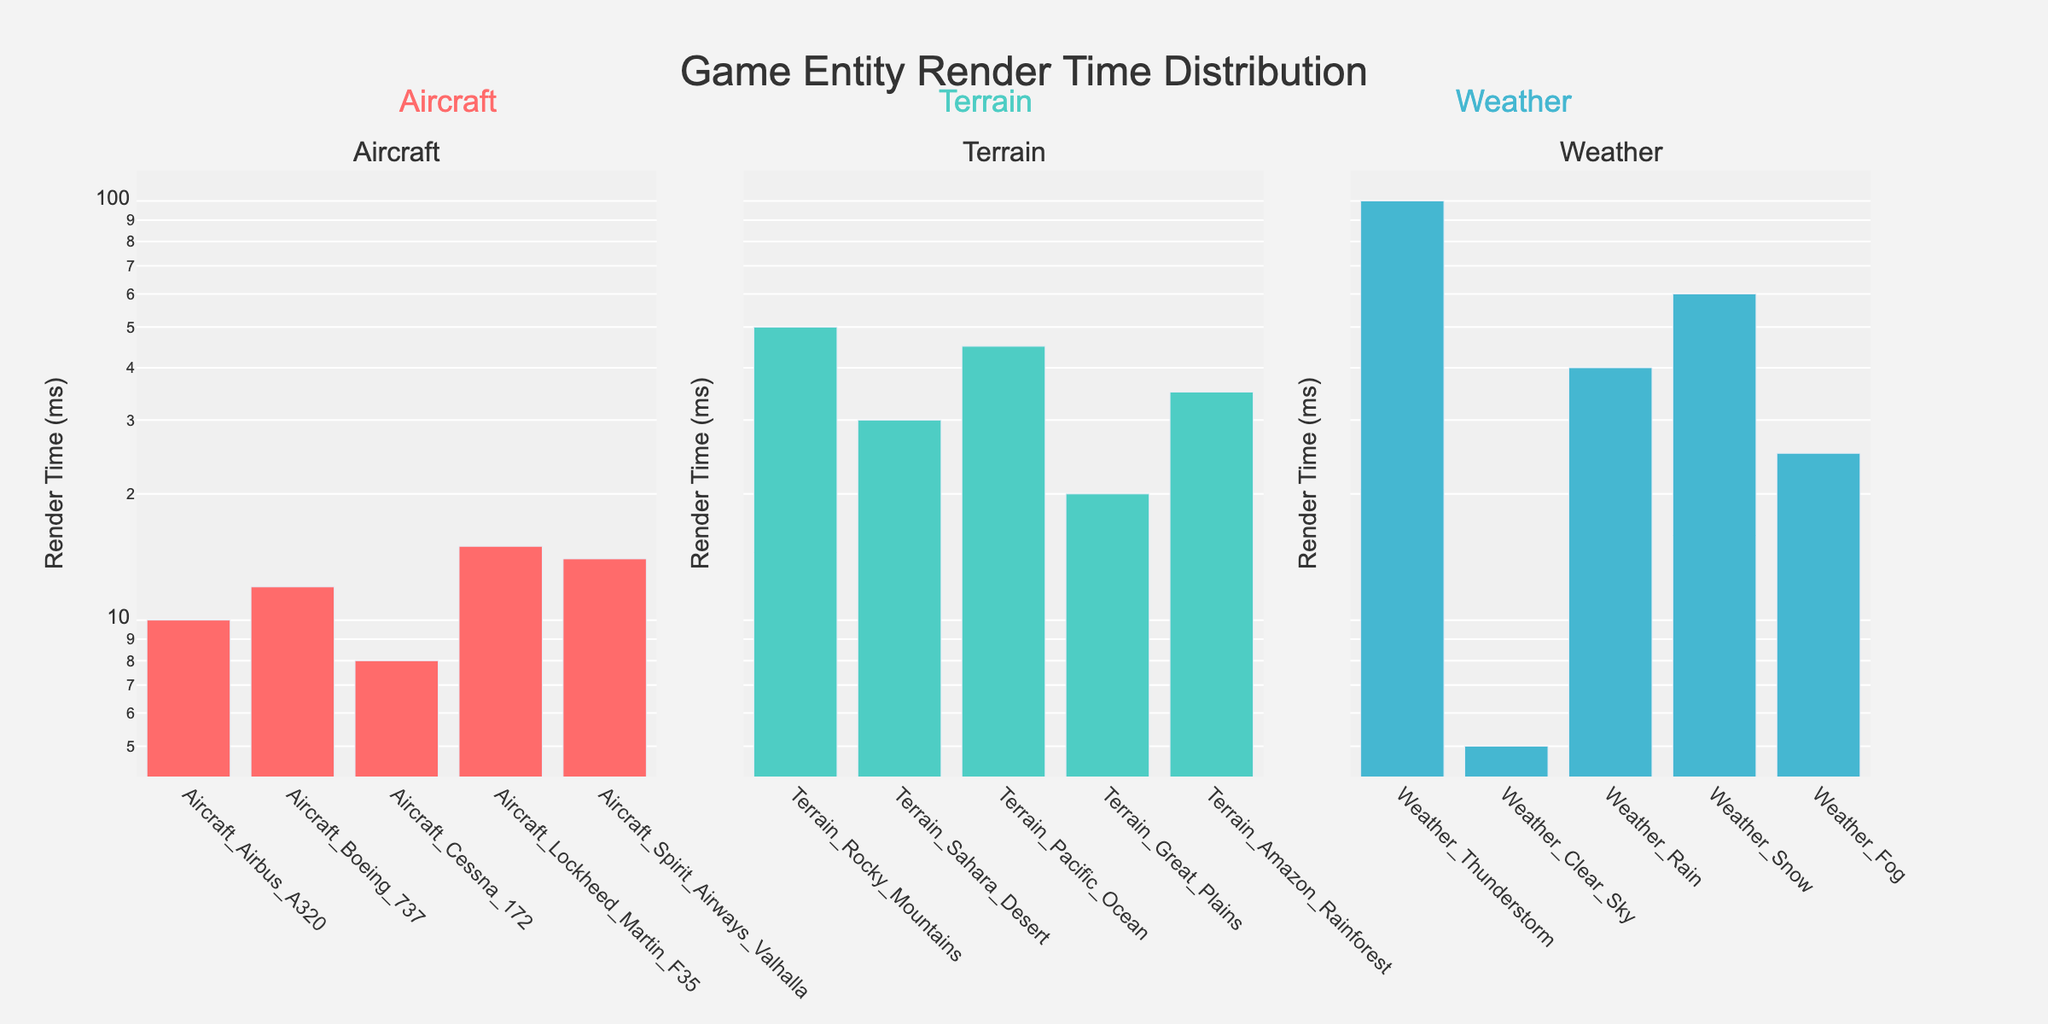How many categories of game entities are shown in the figure? The figure has subplots titled "Aircraft," "Terrain," and "Weather," indicating three categories of game entities.
Answer: Three What is the title of the figure? The title is displayed at the top center of the figure.
Answer: Game Entity Render Time Distribution Which game entity has the highest render time? The highest bar in the subplots represents "Weather_Thunderstorm" under the Weather category with the highest rendering time.
Answer: Weather_Thunderstorm What is the render time of the Terrain_Sahara_Desert entity? Look at the bar labeled "Terrain_Sahara_Desert" in the Terrain category subplot to find its render time.
Answer: 30 ms Which category has the game entity with the lowest render time? By comparing the minimal bars in each category, "Weather_Clear_Sky" in the Weather category has the lowest render time.
Answer: Weather What is the difference in render time between Aircraft_Boeing_737 and Terrain_Rocky_Mountains? Aircraft_Boeing_737 has a render time of 12 ms, and Terrain_Rocky_Mountains has 50 ms. The difference is 50 - 12.
Answer: 38 ms What is the average render time of game entities in the Aircraft category? Add the render times of all entities in the Aircraft category (10 + 12 + 8 + 15 + 14) and divide by the number of entities. (10 + 12 + 8 + 15 + 14) / 5
Answer: 11.8 ms Which category has the most diverse (widest range) render times? Compare the range (max - min) for each category: Aircraft (15 - 8), Terrain (50 - 20), Weather (100 - 5). Weather has the widest range.
Answer: Weather How does the render time of Weather_Snow compare to Aircraft_Spirit_Airways_Valhalla? Weather_Snow has a render time of 60 ms, which is greater than Aircraft_Spirit_Airways_Valhalla's 14 ms.
Answer: Greater Which category generally has the shortest render times based on the log scale? By observing the minimum and general distribution of bars, the Aircraft category shows generally shorter render times.
Answer: Aircraft 